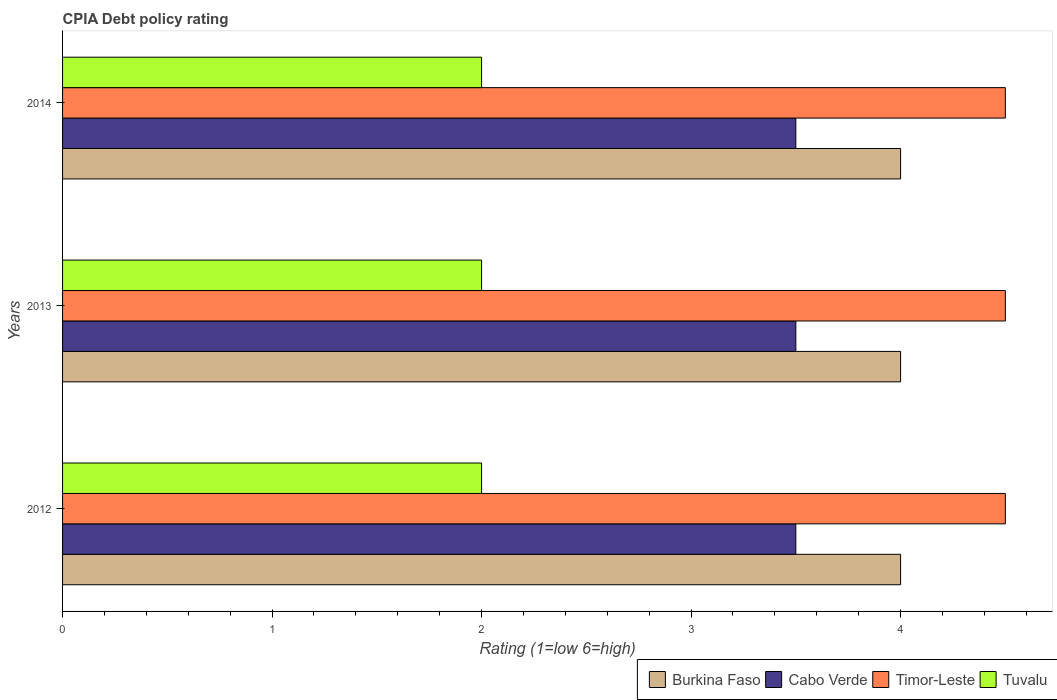How many different coloured bars are there?
Your answer should be compact. 4. Are the number of bars per tick equal to the number of legend labels?
Make the answer very short. Yes. How many bars are there on the 1st tick from the bottom?
Provide a succinct answer. 4. Across all years, what is the minimum CPIA rating in Tuvalu?
Your response must be concise. 2. In which year was the CPIA rating in Cabo Verde minimum?
Provide a short and direct response. 2012. What is the difference between the CPIA rating in Burkina Faso in 2013 and the CPIA rating in Tuvalu in 2012?
Offer a terse response. 2. What is the average CPIA rating in Cabo Verde per year?
Keep it short and to the point. 3.5. In the year 2012, what is the difference between the CPIA rating in Burkina Faso and CPIA rating in Timor-Leste?
Offer a terse response. -0.5. In how many years, is the CPIA rating in Burkina Faso greater than 3.6 ?
Provide a short and direct response. 3. What is the ratio of the CPIA rating in Cabo Verde in 2013 to that in 2014?
Offer a terse response. 1. What is the difference between the highest and the second highest CPIA rating in Cabo Verde?
Offer a terse response. 0. What is the difference between the highest and the lowest CPIA rating in Timor-Leste?
Provide a short and direct response. 0. Is the sum of the CPIA rating in Timor-Leste in 2012 and 2014 greater than the maximum CPIA rating in Burkina Faso across all years?
Offer a terse response. Yes. What does the 3rd bar from the top in 2012 represents?
Your answer should be compact. Cabo Verde. What does the 2nd bar from the bottom in 2013 represents?
Provide a succinct answer. Cabo Verde. Is it the case that in every year, the sum of the CPIA rating in Cabo Verde and CPIA rating in Tuvalu is greater than the CPIA rating in Timor-Leste?
Your response must be concise. Yes. What is the difference between two consecutive major ticks on the X-axis?
Provide a short and direct response. 1. Are the values on the major ticks of X-axis written in scientific E-notation?
Offer a very short reply. No. Does the graph contain any zero values?
Your answer should be compact. No. Where does the legend appear in the graph?
Make the answer very short. Bottom right. What is the title of the graph?
Ensure brevity in your answer.  CPIA Debt policy rating. Does "Least developed countries" appear as one of the legend labels in the graph?
Your answer should be very brief. No. What is the Rating (1=low 6=high) in Cabo Verde in 2012?
Provide a succinct answer. 3.5. What is the Rating (1=low 6=high) of Tuvalu in 2012?
Your answer should be very brief. 2. What is the Rating (1=low 6=high) of Burkina Faso in 2013?
Offer a very short reply. 4. What is the Rating (1=low 6=high) in Timor-Leste in 2013?
Offer a very short reply. 4.5. What is the Rating (1=low 6=high) in Cabo Verde in 2014?
Provide a succinct answer. 3.5. What is the Rating (1=low 6=high) in Tuvalu in 2014?
Keep it short and to the point. 2. Across all years, what is the maximum Rating (1=low 6=high) of Burkina Faso?
Keep it short and to the point. 4. Across all years, what is the maximum Rating (1=low 6=high) of Cabo Verde?
Give a very brief answer. 3.5. Across all years, what is the maximum Rating (1=low 6=high) of Timor-Leste?
Give a very brief answer. 4.5. Across all years, what is the maximum Rating (1=low 6=high) of Tuvalu?
Your response must be concise. 2. Across all years, what is the minimum Rating (1=low 6=high) in Burkina Faso?
Your answer should be compact. 4. Across all years, what is the minimum Rating (1=low 6=high) of Cabo Verde?
Offer a very short reply. 3.5. Across all years, what is the minimum Rating (1=low 6=high) in Timor-Leste?
Provide a short and direct response. 4.5. Across all years, what is the minimum Rating (1=low 6=high) of Tuvalu?
Make the answer very short. 2. What is the total Rating (1=low 6=high) in Timor-Leste in the graph?
Your response must be concise. 13.5. What is the difference between the Rating (1=low 6=high) in Cabo Verde in 2012 and that in 2013?
Keep it short and to the point. 0. What is the difference between the Rating (1=low 6=high) of Timor-Leste in 2012 and that in 2013?
Offer a very short reply. 0. What is the difference between the Rating (1=low 6=high) of Burkina Faso in 2012 and that in 2014?
Your response must be concise. 0. What is the difference between the Rating (1=low 6=high) in Timor-Leste in 2012 and that in 2014?
Offer a very short reply. 0. What is the difference between the Rating (1=low 6=high) in Tuvalu in 2012 and that in 2014?
Provide a short and direct response. 0. What is the difference between the Rating (1=low 6=high) in Timor-Leste in 2013 and that in 2014?
Ensure brevity in your answer.  0. What is the difference between the Rating (1=low 6=high) of Tuvalu in 2013 and that in 2014?
Your answer should be compact. 0. What is the difference between the Rating (1=low 6=high) of Burkina Faso in 2012 and the Rating (1=low 6=high) of Cabo Verde in 2013?
Make the answer very short. 0.5. What is the difference between the Rating (1=low 6=high) of Burkina Faso in 2012 and the Rating (1=low 6=high) of Timor-Leste in 2013?
Provide a short and direct response. -0.5. What is the difference between the Rating (1=low 6=high) of Burkina Faso in 2012 and the Rating (1=low 6=high) of Tuvalu in 2013?
Give a very brief answer. 2. What is the difference between the Rating (1=low 6=high) in Cabo Verde in 2012 and the Rating (1=low 6=high) in Tuvalu in 2013?
Your answer should be compact. 1.5. What is the difference between the Rating (1=low 6=high) of Timor-Leste in 2012 and the Rating (1=low 6=high) of Tuvalu in 2013?
Make the answer very short. 2.5. What is the difference between the Rating (1=low 6=high) in Burkina Faso in 2012 and the Rating (1=low 6=high) in Cabo Verde in 2014?
Offer a terse response. 0.5. What is the difference between the Rating (1=low 6=high) in Burkina Faso in 2012 and the Rating (1=low 6=high) in Timor-Leste in 2014?
Provide a short and direct response. -0.5. What is the difference between the Rating (1=low 6=high) in Cabo Verde in 2012 and the Rating (1=low 6=high) in Timor-Leste in 2014?
Provide a succinct answer. -1. What is the difference between the Rating (1=low 6=high) of Burkina Faso in 2013 and the Rating (1=low 6=high) of Cabo Verde in 2014?
Make the answer very short. 0.5. What is the difference between the Rating (1=low 6=high) of Cabo Verde in 2013 and the Rating (1=low 6=high) of Timor-Leste in 2014?
Make the answer very short. -1. What is the difference between the Rating (1=low 6=high) in Timor-Leste in 2013 and the Rating (1=low 6=high) in Tuvalu in 2014?
Make the answer very short. 2.5. What is the average Rating (1=low 6=high) in Burkina Faso per year?
Provide a succinct answer. 4. In the year 2012, what is the difference between the Rating (1=low 6=high) of Burkina Faso and Rating (1=low 6=high) of Cabo Verde?
Keep it short and to the point. 0.5. In the year 2013, what is the difference between the Rating (1=low 6=high) of Burkina Faso and Rating (1=low 6=high) of Cabo Verde?
Keep it short and to the point. 0.5. In the year 2013, what is the difference between the Rating (1=low 6=high) in Timor-Leste and Rating (1=low 6=high) in Tuvalu?
Offer a very short reply. 2.5. In the year 2014, what is the difference between the Rating (1=low 6=high) in Burkina Faso and Rating (1=low 6=high) in Cabo Verde?
Your answer should be compact. 0.5. In the year 2014, what is the difference between the Rating (1=low 6=high) of Burkina Faso and Rating (1=low 6=high) of Timor-Leste?
Your response must be concise. -0.5. In the year 2014, what is the difference between the Rating (1=low 6=high) in Cabo Verde and Rating (1=low 6=high) in Tuvalu?
Provide a succinct answer. 1.5. What is the ratio of the Rating (1=low 6=high) in Burkina Faso in 2012 to that in 2013?
Give a very brief answer. 1. What is the ratio of the Rating (1=low 6=high) of Cabo Verde in 2012 to that in 2013?
Offer a terse response. 1. What is the ratio of the Rating (1=low 6=high) in Burkina Faso in 2012 to that in 2014?
Give a very brief answer. 1. What is the ratio of the Rating (1=low 6=high) of Cabo Verde in 2012 to that in 2014?
Your answer should be very brief. 1. What is the ratio of the Rating (1=low 6=high) of Tuvalu in 2012 to that in 2014?
Give a very brief answer. 1. What is the ratio of the Rating (1=low 6=high) of Tuvalu in 2013 to that in 2014?
Offer a terse response. 1. What is the difference between the highest and the second highest Rating (1=low 6=high) in Cabo Verde?
Give a very brief answer. 0. What is the difference between the highest and the second highest Rating (1=low 6=high) of Tuvalu?
Ensure brevity in your answer.  0. What is the difference between the highest and the lowest Rating (1=low 6=high) of Burkina Faso?
Give a very brief answer. 0. 